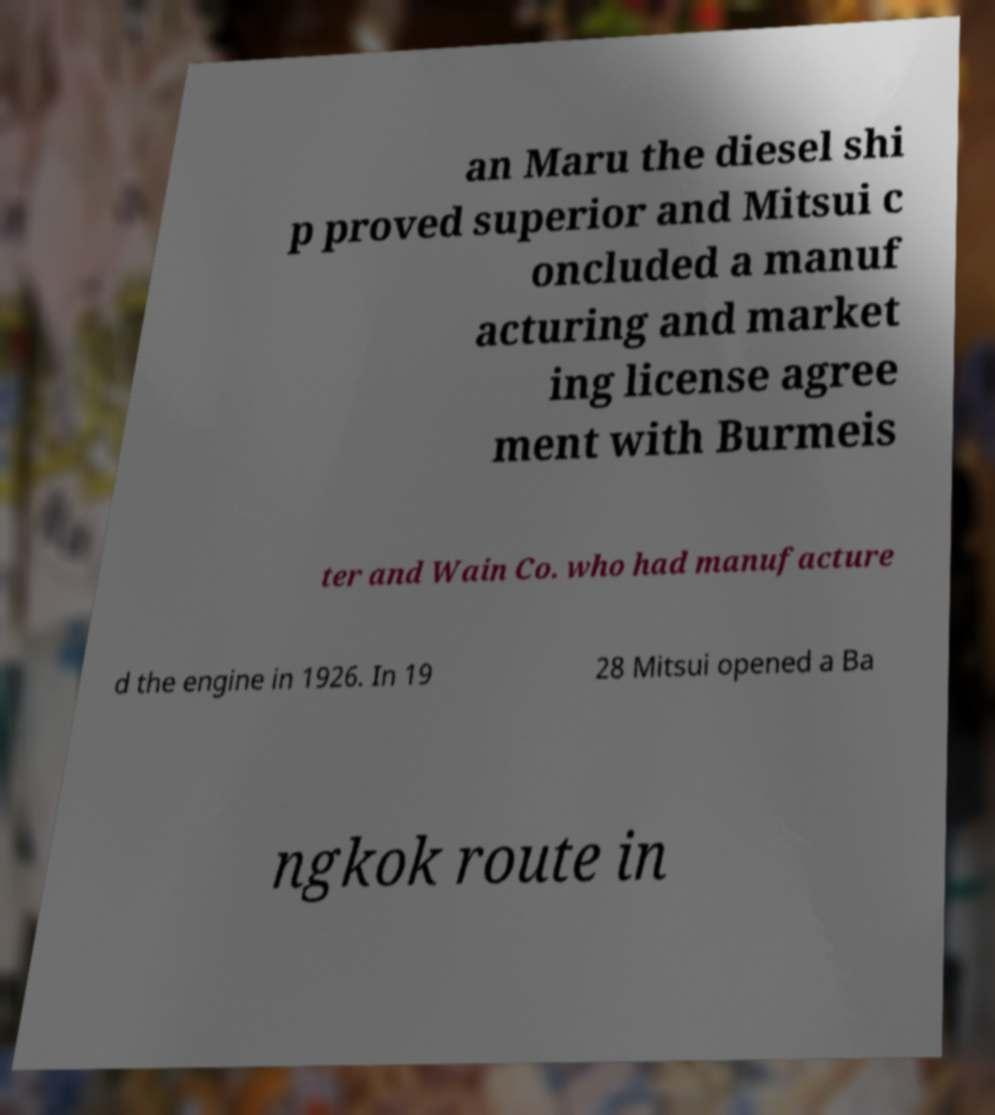There's text embedded in this image that I need extracted. Can you transcribe it verbatim? an Maru the diesel shi p proved superior and Mitsui c oncluded a manuf acturing and market ing license agree ment with Burmeis ter and Wain Co. who had manufacture d the engine in 1926. In 19 28 Mitsui opened a Ba ngkok route in 